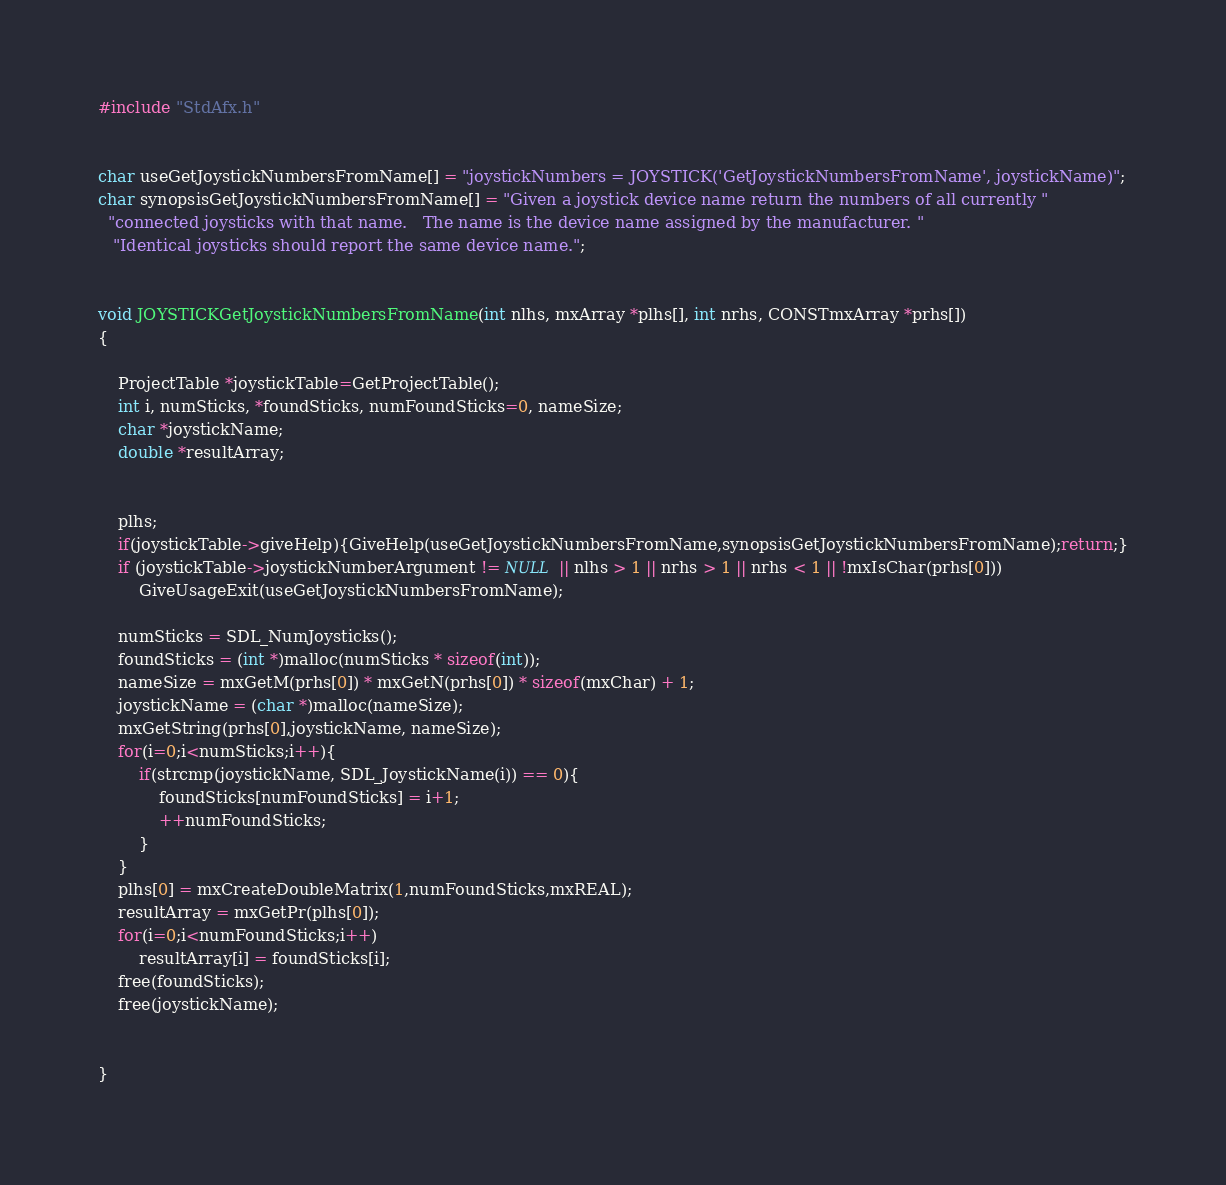<code> <loc_0><loc_0><loc_500><loc_500><_C++_>#include "StdAfx.h"


char useGetJoystickNumbersFromName[] = "joystickNumbers = JOYSTICK('GetJoystickNumbersFromName', joystickName)";
char synopsisGetJoystickNumbersFromName[] = "Given a joystick device name return the numbers of all currently "
  "connected joysticks with that name.   The name is the device name assigned by the manufacturer. "
   "Identical joysticks should report the same device name.";
	

void JOYSTICKGetJoystickNumbersFromName(int nlhs, mxArray *plhs[], int nrhs, CONSTmxArray *prhs[])
{

	ProjectTable *joystickTable=GetProjectTable();
	int i, numSticks, *foundSticks, numFoundSticks=0, nameSize;
	char *joystickName;
	double *resultArray;
	
	
	plhs;
	if(joystickTable->giveHelp){GiveHelp(useGetJoystickNumbersFromName,synopsisGetJoystickNumbersFromName);return;}
	if (joystickTable->joystickNumberArgument != NULL || nlhs > 1 || nrhs > 1 || nrhs < 1 || !mxIsChar(prhs[0]))
		GiveUsageExit(useGetJoystickNumbersFromName);

	numSticks = SDL_NumJoysticks();
	foundSticks = (int *)malloc(numSticks * sizeof(int));
	nameSize = mxGetM(prhs[0]) * mxGetN(prhs[0]) * sizeof(mxChar) + 1;
	joystickName = (char *)malloc(nameSize);
	mxGetString(prhs[0],joystickName, nameSize);
	for(i=0;i<numSticks;i++){
		if(strcmp(joystickName, SDL_JoystickName(i)) == 0){
			foundSticks[numFoundSticks] = i+1;
			++numFoundSticks;
		}
	}
	plhs[0] = mxCreateDoubleMatrix(1,numFoundSticks,mxREAL);
	resultArray = mxGetPr(plhs[0]);
	for(i=0;i<numFoundSticks;i++)
		resultArray[i] = foundSticks[i];
	free(foundSticks);
	free(joystickName);
	

}
</code> 